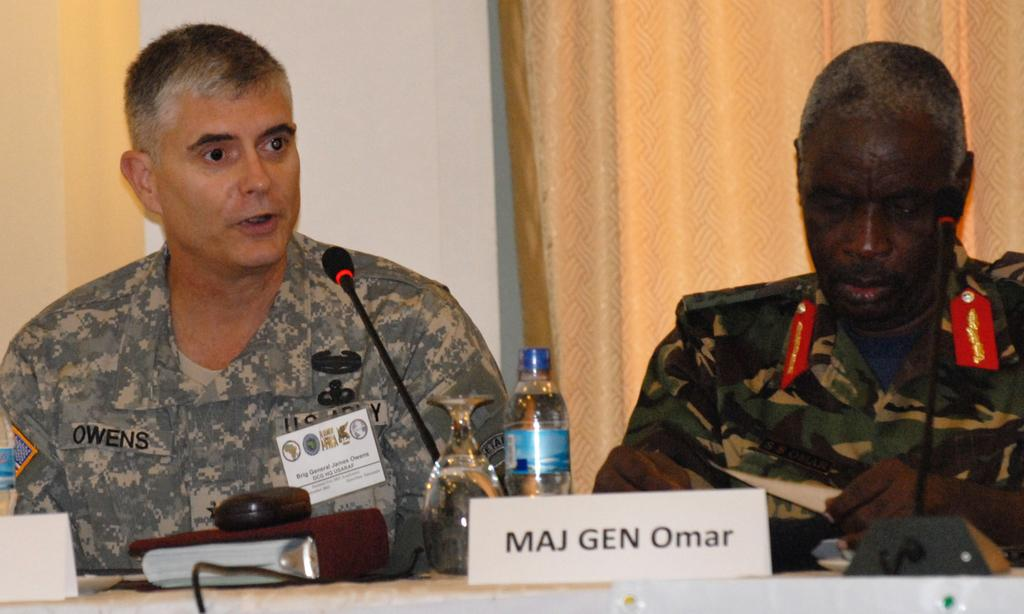How many people are sitting in the image? There are two people sitting in the image. What objects can be seen in the image besides the people? There is a bottle, a glass, a mic, and name boards on the table in the image. What type of carpentry work is being done by the people in the image? There is no carpentry work being done in the image. The people are sitting, and there are no tools or materials related to carpentry present. Can you see a hand in the image? There is no hand visible in the image. The focus is on the people sitting and the objects on the table. Is there a stream visible in the image? No, there is no stream present in the image. The image features two people sitting and objects on a table. 